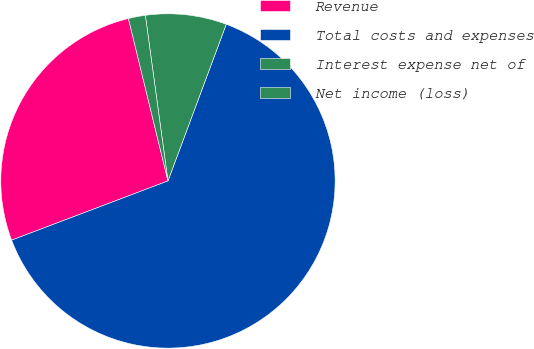Convert chart. <chart><loc_0><loc_0><loc_500><loc_500><pie_chart><fcel>Revenue<fcel>Total costs and expenses<fcel>Interest expense net of<fcel>Net income (loss)<nl><fcel>26.96%<fcel>63.57%<fcel>7.83%<fcel>1.64%<nl></chart> 